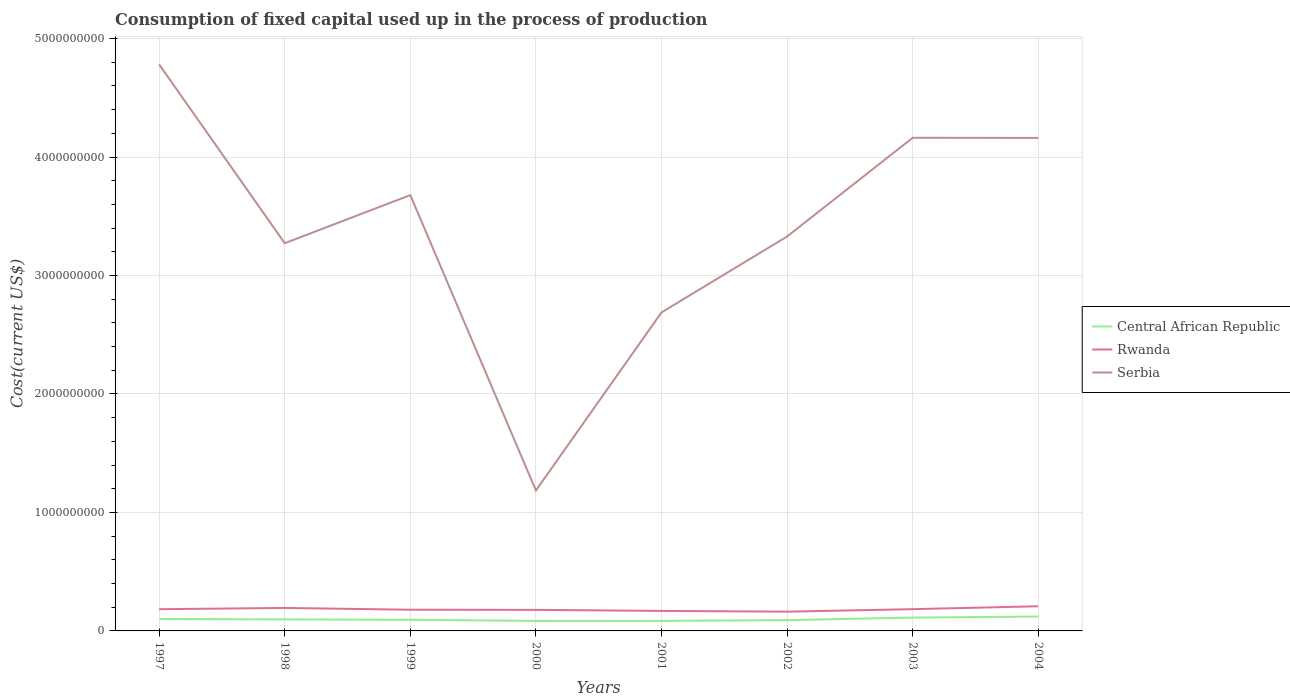How many different coloured lines are there?
Ensure brevity in your answer.  3. Does the line corresponding to Rwanda intersect with the line corresponding to Central African Republic?
Keep it short and to the point. No. Is the number of lines equal to the number of legend labels?
Provide a short and direct response. Yes. Across all years, what is the maximum amount consumed in the process of production in Rwanda?
Make the answer very short. 1.63e+08. What is the total amount consumed in the process of production in Rwanda in the graph?
Offer a terse response. -4.54e+07. What is the difference between the highest and the second highest amount consumed in the process of production in Rwanda?
Offer a very short reply. 4.54e+07. Is the amount consumed in the process of production in Rwanda strictly greater than the amount consumed in the process of production in Serbia over the years?
Your answer should be very brief. Yes. How many lines are there?
Make the answer very short. 3. What is the difference between two consecutive major ticks on the Y-axis?
Keep it short and to the point. 1.00e+09. Are the values on the major ticks of Y-axis written in scientific E-notation?
Your answer should be very brief. No. Where does the legend appear in the graph?
Provide a succinct answer. Center right. What is the title of the graph?
Give a very brief answer. Consumption of fixed capital used up in the process of production. What is the label or title of the X-axis?
Provide a succinct answer. Years. What is the label or title of the Y-axis?
Your response must be concise. Cost(current US$). What is the Cost(current US$) of Central African Republic in 1997?
Provide a short and direct response. 1.01e+08. What is the Cost(current US$) of Rwanda in 1997?
Ensure brevity in your answer.  1.83e+08. What is the Cost(current US$) of Serbia in 1997?
Your response must be concise. 4.78e+09. What is the Cost(current US$) of Central African Republic in 1998?
Provide a succinct answer. 9.70e+07. What is the Cost(current US$) of Rwanda in 1998?
Your answer should be very brief. 1.94e+08. What is the Cost(current US$) of Serbia in 1998?
Your answer should be very brief. 3.27e+09. What is the Cost(current US$) of Central African Republic in 1999?
Provide a short and direct response. 9.39e+07. What is the Cost(current US$) in Rwanda in 1999?
Offer a very short reply. 1.79e+08. What is the Cost(current US$) in Serbia in 1999?
Give a very brief answer. 3.68e+09. What is the Cost(current US$) of Central African Republic in 2000?
Offer a terse response. 8.47e+07. What is the Cost(current US$) in Rwanda in 2000?
Ensure brevity in your answer.  1.78e+08. What is the Cost(current US$) of Serbia in 2000?
Make the answer very short. 1.19e+09. What is the Cost(current US$) in Central African Republic in 2001?
Offer a terse response. 8.50e+07. What is the Cost(current US$) in Rwanda in 2001?
Keep it short and to the point. 1.69e+08. What is the Cost(current US$) of Serbia in 2001?
Ensure brevity in your answer.  2.69e+09. What is the Cost(current US$) in Central African Republic in 2002?
Provide a short and direct response. 9.10e+07. What is the Cost(current US$) in Rwanda in 2002?
Make the answer very short. 1.63e+08. What is the Cost(current US$) in Serbia in 2002?
Provide a succinct answer. 3.33e+09. What is the Cost(current US$) of Central African Republic in 2003?
Keep it short and to the point. 1.12e+08. What is the Cost(current US$) of Rwanda in 2003?
Offer a terse response. 1.84e+08. What is the Cost(current US$) in Serbia in 2003?
Your response must be concise. 4.16e+09. What is the Cost(current US$) of Central African Republic in 2004?
Keep it short and to the point. 1.21e+08. What is the Cost(current US$) in Rwanda in 2004?
Your response must be concise. 2.08e+08. What is the Cost(current US$) in Serbia in 2004?
Give a very brief answer. 4.16e+09. Across all years, what is the maximum Cost(current US$) of Central African Republic?
Make the answer very short. 1.21e+08. Across all years, what is the maximum Cost(current US$) of Rwanda?
Keep it short and to the point. 2.08e+08. Across all years, what is the maximum Cost(current US$) in Serbia?
Provide a succinct answer. 4.78e+09. Across all years, what is the minimum Cost(current US$) in Central African Republic?
Your response must be concise. 8.47e+07. Across all years, what is the minimum Cost(current US$) in Rwanda?
Your response must be concise. 1.63e+08. Across all years, what is the minimum Cost(current US$) of Serbia?
Provide a short and direct response. 1.19e+09. What is the total Cost(current US$) in Central African Republic in the graph?
Keep it short and to the point. 7.86e+08. What is the total Cost(current US$) of Rwanda in the graph?
Provide a succinct answer. 1.46e+09. What is the total Cost(current US$) of Serbia in the graph?
Offer a very short reply. 2.73e+1. What is the difference between the Cost(current US$) in Central African Republic in 1997 and that in 1998?
Your answer should be compact. 3.67e+06. What is the difference between the Cost(current US$) in Rwanda in 1997 and that in 1998?
Ensure brevity in your answer.  -1.07e+07. What is the difference between the Cost(current US$) of Serbia in 1997 and that in 1998?
Make the answer very short. 1.51e+09. What is the difference between the Cost(current US$) in Central African Republic in 1997 and that in 1999?
Keep it short and to the point. 6.76e+06. What is the difference between the Cost(current US$) in Rwanda in 1997 and that in 1999?
Ensure brevity in your answer.  4.52e+06. What is the difference between the Cost(current US$) in Serbia in 1997 and that in 1999?
Give a very brief answer. 1.10e+09. What is the difference between the Cost(current US$) in Central African Republic in 1997 and that in 2000?
Keep it short and to the point. 1.60e+07. What is the difference between the Cost(current US$) in Rwanda in 1997 and that in 2000?
Provide a succinct answer. 5.64e+06. What is the difference between the Cost(current US$) of Serbia in 1997 and that in 2000?
Make the answer very short. 3.60e+09. What is the difference between the Cost(current US$) in Central African Republic in 1997 and that in 2001?
Keep it short and to the point. 1.57e+07. What is the difference between the Cost(current US$) of Rwanda in 1997 and that in 2001?
Give a very brief answer. 1.45e+07. What is the difference between the Cost(current US$) in Serbia in 1997 and that in 2001?
Provide a succinct answer. 2.09e+09. What is the difference between the Cost(current US$) of Central African Republic in 1997 and that in 2002?
Your answer should be very brief. 9.70e+06. What is the difference between the Cost(current US$) of Rwanda in 1997 and that in 2002?
Keep it short and to the point. 2.07e+07. What is the difference between the Cost(current US$) of Serbia in 1997 and that in 2002?
Provide a short and direct response. 1.45e+09. What is the difference between the Cost(current US$) of Central African Republic in 1997 and that in 2003?
Offer a very short reply. -1.18e+07. What is the difference between the Cost(current US$) of Rwanda in 1997 and that in 2003?
Provide a short and direct response. -2.88e+05. What is the difference between the Cost(current US$) of Serbia in 1997 and that in 2003?
Your response must be concise. 6.20e+08. What is the difference between the Cost(current US$) of Central African Republic in 1997 and that in 2004?
Provide a short and direct response. -2.05e+07. What is the difference between the Cost(current US$) in Rwanda in 1997 and that in 2004?
Provide a short and direct response. -2.47e+07. What is the difference between the Cost(current US$) in Serbia in 1997 and that in 2004?
Offer a very short reply. 6.21e+08. What is the difference between the Cost(current US$) in Central African Republic in 1998 and that in 1999?
Your answer should be very brief. 3.10e+06. What is the difference between the Cost(current US$) in Rwanda in 1998 and that in 1999?
Keep it short and to the point. 1.52e+07. What is the difference between the Cost(current US$) of Serbia in 1998 and that in 1999?
Your answer should be very brief. -4.06e+08. What is the difference between the Cost(current US$) of Central African Republic in 1998 and that in 2000?
Your answer should be very brief. 1.24e+07. What is the difference between the Cost(current US$) of Rwanda in 1998 and that in 2000?
Keep it short and to the point. 1.63e+07. What is the difference between the Cost(current US$) of Serbia in 1998 and that in 2000?
Provide a short and direct response. 2.09e+09. What is the difference between the Cost(current US$) of Central African Republic in 1998 and that in 2001?
Offer a terse response. 1.21e+07. What is the difference between the Cost(current US$) of Rwanda in 1998 and that in 2001?
Offer a very short reply. 2.52e+07. What is the difference between the Cost(current US$) in Serbia in 1998 and that in 2001?
Your answer should be compact. 5.84e+08. What is the difference between the Cost(current US$) of Central African Republic in 1998 and that in 2002?
Provide a succinct answer. 6.04e+06. What is the difference between the Cost(current US$) of Rwanda in 1998 and that in 2002?
Offer a very short reply. 3.14e+07. What is the difference between the Cost(current US$) in Serbia in 1998 and that in 2002?
Ensure brevity in your answer.  -5.67e+07. What is the difference between the Cost(current US$) in Central African Republic in 1998 and that in 2003?
Provide a short and direct response. -1.54e+07. What is the difference between the Cost(current US$) of Rwanda in 1998 and that in 2003?
Provide a succinct answer. 1.04e+07. What is the difference between the Cost(current US$) of Serbia in 1998 and that in 2003?
Make the answer very short. -8.90e+08. What is the difference between the Cost(current US$) of Central African Republic in 1998 and that in 2004?
Provide a succinct answer. -2.42e+07. What is the difference between the Cost(current US$) of Rwanda in 1998 and that in 2004?
Provide a short and direct response. -1.41e+07. What is the difference between the Cost(current US$) in Serbia in 1998 and that in 2004?
Your response must be concise. -8.89e+08. What is the difference between the Cost(current US$) of Central African Republic in 1999 and that in 2000?
Ensure brevity in your answer.  9.26e+06. What is the difference between the Cost(current US$) in Rwanda in 1999 and that in 2000?
Offer a terse response. 1.11e+06. What is the difference between the Cost(current US$) of Serbia in 1999 and that in 2000?
Provide a short and direct response. 2.49e+09. What is the difference between the Cost(current US$) of Central African Republic in 1999 and that in 2001?
Provide a succinct answer. 8.97e+06. What is the difference between the Cost(current US$) of Rwanda in 1999 and that in 2001?
Make the answer very short. 1.00e+07. What is the difference between the Cost(current US$) in Serbia in 1999 and that in 2001?
Give a very brief answer. 9.90e+08. What is the difference between the Cost(current US$) in Central African Republic in 1999 and that in 2002?
Keep it short and to the point. 2.94e+06. What is the difference between the Cost(current US$) in Rwanda in 1999 and that in 2002?
Your response must be concise. 1.62e+07. What is the difference between the Cost(current US$) of Serbia in 1999 and that in 2002?
Provide a short and direct response. 3.50e+08. What is the difference between the Cost(current US$) of Central African Republic in 1999 and that in 2003?
Offer a very short reply. -1.85e+07. What is the difference between the Cost(current US$) in Rwanda in 1999 and that in 2003?
Keep it short and to the point. -4.81e+06. What is the difference between the Cost(current US$) in Serbia in 1999 and that in 2003?
Keep it short and to the point. -4.84e+08. What is the difference between the Cost(current US$) of Central African Republic in 1999 and that in 2004?
Provide a succinct answer. -2.73e+07. What is the difference between the Cost(current US$) of Rwanda in 1999 and that in 2004?
Give a very brief answer. -2.92e+07. What is the difference between the Cost(current US$) of Serbia in 1999 and that in 2004?
Ensure brevity in your answer.  -4.83e+08. What is the difference between the Cost(current US$) in Central African Republic in 2000 and that in 2001?
Provide a succinct answer. -2.96e+05. What is the difference between the Cost(current US$) in Rwanda in 2000 and that in 2001?
Give a very brief answer. 8.90e+06. What is the difference between the Cost(current US$) of Serbia in 2000 and that in 2001?
Offer a very short reply. -1.50e+09. What is the difference between the Cost(current US$) of Central African Republic in 2000 and that in 2002?
Provide a short and direct response. -6.32e+06. What is the difference between the Cost(current US$) of Rwanda in 2000 and that in 2002?
Offer a terse response. 1.51e+07. What is the difference between the Cost(current US$) of Serbia in 2000 and that in 2002?
Your response must be concise. -2.14e+09. What is the difference between the Cost(current US$) of Central African Republic in 2000 and that in 2003?
Give a very brief answer. -2.78e+07. What is the difference between the Cost(current US$) of Rwanda in 2000 and that in 2003?
Give a very brief answer. -5.92e+06. What is the difference between the Cost(current US$) of Serbia in 2000 and that in 2003?
Provide a short and direct response. -2.98e+09. What is the difference between the Cost(current US$) in Central African Republic in 2000 and that in 2004?
Provide a short and direct response. -3.65e+07. What is the difference between the Cost(current US$) in Rwanda in 2000 and that in 2004?
Your response must be concise. -3.03e+07. What is the difference between the Cost(current US$) of Serbia in 2000 and that in 2004?
Offer a very short reply. -2.98e+09. What is the difference between the Cost(current US$) of Central African Republic in 2001 and that in 2002?
Make the answer very short. -6.03e+06. What is the difference between the Cost(current US$) in Rwanda in 2001 and that in 2002?
Keep it short and to the point. 6.20e+06. What is the difference between the Cost(current US$) in Serbia in 2001 and that in 2002?
Keep it short and to the point. -6.41e+08. What is the difference between the Cost(current US$) of Central African Republic in 2001 and that in 2003?
Make the answer very short. -2.75e+07. What is the difference between the Cost(current US$) of Rwanda in 2001 and that in 2003?
Give a very brief answer. -1.48e+07. What is the difference between the Cost(current US$) of Serbia in 2001 and that in 2003?
Your response must be concise. -1.47e+09. What is the difference between the Cost(current US$) of Central African Republic in 2001 and that in 2004?
Provide a short and direct response. -3.62e+07. What is the difference between the Cost(current US$) of Rwanda in 2001 and that in 2004?
Your response must be concise. -3.92e+07. What is the difference between the Cost(current US$) of Serbia in 2001 and that in 2004?
Your response must be concise. -1.47e+09. What is the difference between the Cost(current US$) in Central African Republic in 2002 and that in 2003?
Offer a very short reply. -2.15e+07. What is the difference between the Cost(current US$) of Rwanda in 2002 and that in 2003?
Provide a succinct answer. -2.10e+07. What is the difference between the Cost(current US$) in Serbia in 2002 and that in 2003?
Make the answer very short. -8.33e+08. What is the difference between the Cost(current US$) of Central African Republic in 2002 and that in 2004?
Make the answer very short. -3.02e+07. What is the difference between the Cost(current US$) of Rwanda in 2002 and that in 2004?
Your answer should be very brief. -4.54e+07. What is the difference between the Cost(current US$) of Serbia in 2002 and that in 2004?
Give a very brief answer. -8.32e+08. What is the difference between the Cost(current US$) of Central African Republic in 2003 and that in 2004?
Provide a short and direct response. -8.74e+06. What is the difference between the Cost(current US$) in Rwanda in 2003 and that in 2004?
Give a very brief answer. -2.44e+07. What is the difference between the Cost(current US$) of Serbia in 2003 and that in 2004?
Give a very brief answer. 1.14e+06. What is the difference between the Cost(current US$) in Central African Republic in 1997 and the Cost(current US$) in Rwanda in 1998?
Give a very brief answer. -9.33e+07. What is the difference between the Cost(current US$) of Central African Republic in 1997 and the Cost(current US$) of Serbia in 1998?
Provide a succinct answer. -3.17e+09. What is the difference between the Cost(current US$) of Rwanda in 1997 and the Cost(current US$) of Serbia in 1998?
Provide a short and direct response. -3.09e+09. What is the difference between the Cost(current US$) of Central African Republic in 1997 and the Cost(current US$) of Rwanda in 1999?
Your answer should be compact. -7.82e+07. What is the difference between the Cost(current US$) of Central African Republic in 1997 and the Cost(current US$) of Serbia in 1999?
Provide a short and direct response. -3.58e+09. What is the difference between the Cost(current US$) in Rwanda in 1997 and the Cost(current US$) in Serbia in 1999?
Give a very brief answer. -3.50e+09. What is the difference between the Cost(current US$) of Central African Republic in 1997 and the Cost(current US$) of Rwanda in 2000?
Offer a terse response. -7.70e+07. What is the difference between the Cost(current US$) of Central African Republic in 1997 and the Cost(current US$) of Serbia in 2000?
Your answer should be compact. -1.08e+09. What is the difference between the Cost(current US$) of Rwanda in 1997 and the Cost(current US$) of Serbia in 2000?
Make the answer very short. -1.00e+09. What is the difference between the Cost(current US$) in Central African Republic in 1997 and the Cost(current US$) in Rwanda in 2001?
Your response must be concise. -6.81e+07. What is the difference between the Cost(current US$) of Central African Republic in 1997 and the Cost(current US$) of Serbia in 2001?
Ensure brevity in your answer.  -2.59e+09. What is the difference between the Cost(current US$) of Rwanda in 1997 and the Cost(current US$) of Serbia in 2001?
Make the answer very short. -2.51e+09. What is the difference between the Cost(current US$) in Central African Republic in 1997 and the Cost(current US$) in Rwanda in 2002?
Give a very brief answer. -6.19e+07. What is the difference between the Cost(current US$) of Central African Republic in 1997 and the Cost(current US$) of Serbia in 2002?
Offer a very short reply. -3.23e+09. What is the difference between the Cost(current US$) of Rwanda in 1997 and the Cost(current US$) of Serbia in 2002?
Provide a short and direct response. -3.15e+09. What is the difference between the Cost(current US$) in Central African Republic in 1997 and the Cost(current US$) in Rwanda in 2003?
Provide a short and direct response. -8.30e+07. What is the difference between the Cost(current US$) in Central African Republic in 1997 and the Cost(current US$) in Serbia in 2003?
Your answer should be compact. -4.06e+09. What is the difference between the Cost(current US$) in Rwanda in 1997 and the Cost(current US$) in Serbia in 2003?
Your answer should be very brief. -3.98e+09. What is the difference between the Cost(current US$) in Central African Republic in 1997 and the Cost(current US$) in Rwanda in 2004?
Your answer should be compact. -1.07e+08. What is the difference between the Cost(current US$) in Central African Republic in 1997 and the Cost(current US$) in Serbia in 2004?
Ensure brevity in your answer.  -4.06e+09. What is the difference between the Cost(current US$) in Rwanda in 1997 and the Cost(current US$) in Serbia in 2004?
Ensure brevity in your answer.  -3.98e+09. What is the difference between the Cost(current US$) of Central African Republic in 1998 and the Cost(current US$) of Rwanda in 1999?
Your response must be concise. -8.18e+07. What is the difference between the Cost(current US$) of Central African Republic in 1998 and the Cost(current US$) of Serbia in 1999?
Ensure brevity in your answer.  -3.58e+09. What is the difference between the Cost(current US$) of Rwanda in 1998 and the Cost(current US$) of Serbia in 1999?
Provide a short and direct response. -3.48e+09. What is the difference between the Cost(current US$) of Central African Republic in 1998 and the Cost(current US$) of Rwanda in 2000?
Offer a very short reply. -8.07e+07. What is the difference between the Cost(current US$) of Central African Republic in 1998 and the Cost(current US$) of Serbia in 2000?
Give a very brief answer. -1.09e+09. What is the difference between the Cost(current US$) in Rwanda in 1998 and the Cost(current US$) in Serbia in 2000?
Ensure brevity in your answer.  -9.91e+08. What is the difference between the Cost(current US$) of Central African Republic in 1998 and the Cost(current US$) of Rwanda in 2001?
Offer a terse response. -7.18e+07. What is the difference between the Cost(current US$) in Central African Republic in 1998 and the Cost(current US$) in Serbia in 2001?
Ensure brevity in your answer.  -2.59e+09. What is the difference between the Cost(current US$) of Rwanda in 1998 and the Cost(current US$) of Serbia in 2001?
Your answer should be very brief. -2.49e+09. What is the difference between the Cost(current US$) of Central African Republic in 1998 and the Cost(current US$) of Rwanda in 2002?
Your answer should be compact. -6.56e+07. What is the difference between the Cost(current US$) in Central African Republic in 1998 and the Cost(current US$) in Serbia in 2002?
Give a very brief answer. -3.23e+09. What is the difference between the Cost(current US$) in Rwanda in 1998 and the Cost(current US$) in Serbia in 2002?
Make the answer very short. -3.14e+09. What is the difference between the Cost(current US$) in Central African Republic in 1998 and the Cost(current US$) in Rwanda in 2003?
Ensure brevity in your answer.  -8.66e+07. What is the difference between the Cost(current US$) in Central African Republic in 1998 and the Cost(current US$) in Serbia in 2003?
Provide a succinct answer. -4.07e+09. What is the difference between the Cost(current US$) of Rwanda in 1998 and the Cost(current US$) of Serbia in 2003?
Offer a very short reply. -3.97e+09. What is the difference between the Cost(current US$) of Central African Republic in 1998 and the Cost(current US$) of Rwanda in 2004?
Your answer should be compact. -1.11e+08. What is the difference between the Cost(current US$) of Central African Republic in 1998 and the Cost(current US$) of Serbia in 2004?
Offer a very short reply. -4.06e+09. What is the difference between the Cost(current US$) of Rwanda in 1998 and the Cost(current US$) of Serbia in 2004?
Give a very brief answer. -3.97e+09. What is the difference between the Cost(current US$) in Central African Republic in 1999 and the Cost(current US$) in Rwanda in 2000?
Provide a succinct answer. -8.38e+07. What is the difference between the Cost(current US$) of Central African Republic in 1999 and the Cost(current US$) of Serbia in 2000?
Offer a terse response. -1.09e+09. What is the difference between the Cost(current US$) of Rwanda in 1999 and the Cost(current US$) of Serbia in 2000?
Ensure brevity in your answer.  -1.01e+09. What is the difference between the Cost(current US$) of Central African Republic in 1999 and the Cost(current US$) of Rwanda in 2001?
Your response must be concise. -7.49e+07. What is the difference between the Cost(current US$) in Central African Republic in 1999 and the Cost(current US$) in Serbia in 2001?
Provide a succinct answer. -2.59e+09. What is the difference between the Cost(current US$) of Rwanda in 1999 and the Cost(current US$) of Serbia in 2001?
Provide a short and direct response. -2.51e+09. What is the difference between the Cost(current US$) in Central African Republic in 1999 and the Cost(current US$) in Rwanda in 2002?
Provide a succinct answer. -6.87e+07. What is the difference between the Cost(current US$) of Central African Republic in 1999 and the Cost(current US$) of Serbia in 2002?
Provide a succinct answer. -3.24e+09. What is the difference between the Cost(current US$) of Rwanda in 1999 and the Cost(current US$) of Serbia in 2002?
Keep it short and to the point. -3.15e+09. What is the difference between the Cost(current US$) of Central African Republic in 1999 and the Cost(current US$) of Rwanda in 2003?
Ensure brevity in your answer.  -8.97e+07. What is the difference between the Cost(current US$) of Central African Republic in 1999 and the Cost(current US$) of Serbia in 2003?
Provide a short and direct response. -4.07e+09. What is the difference between the Cost(current US$) of Rwanda in 1999 and the Cost(current US$) of Serbia in 2003?
Your response must be concise. -3.98e+09. What is the difference between the Cost(current US$) of Central African Republic in 1999 and the Cost(current US$) of Rwanda in 2004?
Provide a succinct answer. -1.14e+08. What is the difference between the Cost(current US$) of Central African Republic in 1999 and the Cost(current US$) of Serbia in 2004?
Keep it short and to the point. -4.07e+09. What is the difference between the Cost(current US$) of Rwanda in 1999 and the Cost(current US$) of Serbia in 2004?
Give a very brief answer. -3.98e+09. What is the difference between the Cost(current US$) in Central African Republic in 2000 and the Cost(current US$) in Rwanda in 2001?
Your response must be concise. -8.42e+07. What is the difference between the Cost(current US$) in Central African Republic in 2000 and the Cost(current US$) in Serbia in 2001?
Give a very brief answer. -2.60e+09. What is the difference between the Cost(current US$) in Rwanda in 2000 and the Cost(current US$) in Serbia in 2001?
Make the answer very short. -2.51e+09. What is the difference between the Cost(current US$) in Central African Republic in 2000 and the Cost(current US$) in Rwanda in 2002?
Your response must be concise. -7.80e+07. What is the difference between the Cost(current US$) of Central African Republic in 2000 and the Cost(current US$) of Serbia in 2002?
Your answer should be compact. -3.24e+09. What is the difference between the Cost(current US$) of Rwanda in 2000 and the Cost(current US$) of Serbia in 2002?
Keep it short and to the point. -3.15e+09. What is the difference between the Cost(current US$) of Central African Republic in 2000 and the Cost(current US$) of Rwanda in 2003?
Your response must be concise. -9.90e+07. What is the difference between the Cost(current US$) in Central African Republic in 2000 and the Cost(current US$) in Serbia in 2003?
Your response must be concise. -4.08e+09. What is the difference between the Cost(current US$) in Rwanda in 2000 and the Cost(current US$) in Serbia in 2003?
Your response must be concise. -3.99e+09. What is the difference between the Cost(current US$) of Central African Republic in 2000 and the Cost(current US$) of Rwanda in 2004?
Offer a terse response. -1.23e+08. What is the difference between the Cost(current US$) of Central African Republic in 2000 and the Cost(current US$) of Serbia in 2004?
Provide a short and direct response. -4.08e+09. What is the difference between the Cost(current US$) of Rwanda in 2000 and the Cost(current US$) of Serbia in 2004?
Keep it short and to the point. -3.98e+09. What is the difference between the Cost(current US$) of Central African Republic in 2001 and the Cost(current US$) of Rwanda in 2002?
Keep it short and to the point. -7.77e+07. What is the difference between the Cost(current US$) of Central African Republic in 2001 and the Cost(current US$) of Serbia in 2002?
Make the answer very short. -3.24e+09. What is the difference between the Cost(current US$) of Rwanda in 2001 and the Cost(current US$) of Serbia in 2002?
Give a very brief answer. -3.16e+09. What is the difference between the Cost(current US$) in Central African Republic in 2001 and the Cost(current US$) in Rwanda in 2003?
Make the answer very short. -9.87e+07. What is the difference between the Cost(current US$) in Central African Republic in 2001 and the Cost(current US$) in Serbia in 2003?
Offer a terse response. -4.08e+09. What is the difference between the Cost(current US$) of Rwanda in 2001 and the Cost(current US$) of Serbia in 2003?
Your answer should be very brief. -3.99e+09. What is the difference between the Cost(current US$) of Central African Republic in 2001 and the Cost(current US$) of Rwanda in 2004?
Offer a terse response. -1.23e+08. What is the difference between the Cost(current US$) of Central African Republic in 2001 and the Cost(current US$) of Serbia in 2004?
Give a very brief answer. -4.08e+09. What is the difference between the Cost(current US$) of Rwanda in 2001 and the Cost(current US$) of Serbia in 2004?
Your response must be concise. -3.99e+09. What is the difference between the Cost(current US$) in Central African Republic in 2002 and the Cost(current US$) in Rwanda in 2003?
Give a very brief answer. -9.27e+07. What is the difference between the Cost(current US$) in Central African Republic in 2002 and the Cost(current US$) in Serbia in 2003?
Offer a terse response. -4.07e+09. What is the difference between the Cost(current US$) in Rwanda in 2002 and the Cost(current US$) in Serbia in 2003?
Offer a very short reply. -4.00e+09. What is the difference between the Cost(current US$) of Central African Republic in 2002 and the Cost(current US$) of Rwanda in 2004?
Make the answer very short. -1.17e+08. What is the difference between the Cost(current US$) of Central African Republic in 2002 and the Cost(current US$) of Serbia in 2004?
Your answer should be compact. -4.07e+09. What is the difference between the Cost(current US$) in Rwanda in 2002 and the Cost(current US$) in Serbia in 2004?
Provide a succinct answer. -4.00e+09. What is the difference between the Cost(current US$) of Central African Republic in 2003 and the Cost(current US$) of Rwanda in 2004?
Offer a terse response. -9.56e+07. What is the difference between the Cost(current US$) of Central African Republic in 2003 and the Cost(current US$) of Serbia in 2004?
Offer a terse response. -4.05e+09. What is the difference between the Cost(current US$) in Rwanda in 2003 and the Cost(current US$) in Serbia in 2004?
Provide a short and direct response. -3.98e+09. What is the average Cost(current US$) of Central African Republic per year?
Provide a short and direct response. 9.82e+07. What is the average Cost(current US$) of Rwanda per year?
Ensure brevity in your answer.  1.82e+08. What is the average Cost(current US$) of Serbia per year?
Keep it short and to the point. 3.41e+09. In the year 1997, what is the difference between the Cost(current US$) in Central African Republic and Cost(current US$) in Rwanda?
Your response must be concise. -8.27e+07. In the year 1997, what is the difference between the Cost(current US$) in Central African Republic and Cost(current US$) in Serbia?
Your answer should be compact. -4.68e+09. In the year 1997, what is the difference between the Cost(current US$) in Rwanda and Cost(current US$) in Serbia?
Ensure brevity in your answer.  -4.60e+09. In the year 1998, what is the difference between the Cost(current US$) in Central African Republic and Cost(current US$) in Rwanda?
Ensure brevity in your answer.  -9.70e+07. In the year 1998, what is the difference between the Cost(current US$) in Central African Republic and Cost(current US$) in Serbia?
Provide a short and direct response. -3.18e+09. In the year 1998, what is the difference between the Cost(current US$) in Rwanda and Cost(current US$) in Serbia?
Ensure brevity in your answer.  -3.08e+09. In the year 1999, what is the difference between the Cost(current US$) in Central African Republic and Cost(current US$) in Rwanda?
Ensure brevity in your answer.  -8.49e+07. In the year 1999, what is the difference between the Cost(current US$) of Central African Republic and Cost(current US$) of Serbia?
Provide a short and direct response. -3.58e+09. In the year 1999, what is the difference between the Cost(current US$) in Rwanda and Cost(current US$) in Serbia?
Make the answer very short. -3.50e+09. In the year 2000, what is the difference between the Cost(current US$) in Central African Republic and Cost(current US$) in Rwanda?
Offer a very short reply. -9.31e+07. In the year 2000, what is the difference between the Cost(current US$) of Central African Republic and Cost(current US$) of Serbia?
Provide a succinct answer. -1.10e+09. In the year 2000, what is the difference between the Cost(current US$) in Rwanda and Cost(current US$) in Serbia?
Offer a terse response. -1.01e+09. In the year 2001, what is the difference between the Cost(current US$) in Central African Republic and Cost(current US$) in Rwanda?
Keep it short and to the point. -8.39e+07. In the year 2001, what is the difference between the Cost(current US$) of Central African Republic and Cost(current US$) of Serbia?
Ensure brevity in your answer.  -2.60e+09. In the year 2001, what is the difference between the Cost(current US$) of Rwanda and Cost(current US$) of Serbia?
Offer a terse response. -2.52e+09. In the year 2002, what is the difference between the Cost(current US$) of Central African Republic and Cost(current US$) of Rwanda?
Keep it short and to the point. -7.16e+07. In the year 2002, what is the difference between the Cost(current US$) of Central African Republic and Cost(current US$) of Serbia?
Your answer should be compact. -3.24e+09. In the year 2002, what is the difference between the Cost(current US$) in Rwanda and Cost(current US$) in Serbia?
Keep it short and to the point. -3.17e+09. In the year 2003, what is the difference between the Cost(current US$) of Central African Republic and Cost(current US$) of Rwanda?
Provide a succinct answer. -7.12e+07. In the year 2003, what is the difference between the Cost(current US$) in Central African Republic and Cost(current US$) in Serbia?
Give a very brief answer. -4.05e+09. In the year 2003, what is the difference between the Cost(current US$) in Rwanda and Cost(current US$) in Serbia?
Offer a very short reply. -3.98e+09. In the year 2004, what is the difference between the Cost(current US$) in Central African Republic and Cost(current US$) in Rwanda?
Keep it short and to the point. -8.69e+07. In the year 2004, what is the difference between the Cost(current US$) in Central African Republic and Cost(current US$) in Serbia?
Your answer should be very brief. -4.04e+09. In the year 2004, what is the difference between the Cost(current US$) of Rwanda and Cost(current US$) of Serbia?
Your response must be concise. -3.95e+09. What is the ratio of the Cost(current US$) of Central African Republic in 1997 to that in 1998?
Provide a short and direct response. 1.04. What is the ratio of the Cost(current US$) of Rwanda in 1997 to that in 1998?
Ensure brevity in your answer.  0.95. What is the ratio of the Cost(current US$) of Serbia in 1997 to that in 1998?
Provide a succinct answer. 1.46. What is the ratio of the Cost(current US$) of Central African Republic in 1997 to that in 1999?
Make the answer very short. 1.07. What is the ratio of the Cost(current US$) in Rwanda in 1997 to that in 1999?
Provide a succinct answer. 1.03. What is the ratio of the Cost(current US$) in Serbia in 1997 to that in 1999?
Keep it short and to the point. 1.3. What is the ratio of the Cost(current US$) of Central African Republic in 1997 to that in 2000?
Keep it short and to the point. 1.19. What is the ratio of the Cost(current US$) in Rwanda in 1997 to that in 2000?
Provide a short and direct response. 1.03. What is the ratio of the Cost(current US$) in Serbia in 1997 to that in 2000?
Your answer should be very brief. 4.03. What is the ratio of the Cost(current US$) in Central African Republic in 1997 to that in 2001?
Provide a succinct answer. 1.19. What is the ratio of the Cost(current US$) of Rwanda in 1997 to that in 2001?
Offer a terse response. 1.09. What is the ratio of the Cost(current US$) of Serbia in 1997 to that in 2001?
Offer a terse response. 1.78. What is the ratio of the Cost(current US$) in Central African Republic in 1997 to that in 2002?
Make the answer very short. 1.11. What is the ratio of the Cost(current US$) in Rwanda in 1997 to that in 2002?
Provide a succinct answer. 1.13. What is the ratio of the Cost(current US$) in Serbia in 1997 to that in 2002?
Your answer should be compact. 1.44. What is the ratio of the Cost(current US$) of Central African Republic in 1997 to that in 2003?
Provide a succinct answer. 0.9. What is the ratio of the Cost(current US$) of Rwanda in 1997 to that in 2003?
Offer a terse response. 1. What is the ratio of the Cost(current US$) in Serbia in 1997 to that in 2003?
Your answer should be compact. 1.15. What is the ratio of the Cost(current US$) of Central African Republic in 1997 to that in 2004?
Your response must be concise. 0.83. What is the ratio of the Cost(current US$) of Rwanda in 1997 to that in 2004?
Offer a terse response. 0.88. What is the ratio of the Cost(current US$) in Serbia in 1997 to that in 2004?
Your response must be concise. 1.15. What is the ratio of the Cost(current US$) of Central African Republic in 1998 to that in 1999?
Provide a succinct answer. 1.03. What is the ratio of the Cost(current US$) in Rwanda in 1998 to that in 1999?
Make the answer very short. 1.08. What is the ratio of the Cost(current US$) of Serbia in 1998 to that in 1999?
Your answer should be compact. 0.89. What is the ratio of the Cost(current US$) of Central African Republic in 1998 to that in 2000?
Provide a succinct answer. 1.15. What is the ratio of the Cost(current US$) of Rwanda in 1998 to that in 2000?
Give a very brief answer. 1.09. What is the ratio of the Cost(current US$) of Serbia in 1998 to that in 2000?
Make the answer very short. 2.76. What is the ratio of the Cost(current US$) in Central African Republic in 1998 to that in 2001?
Your answer should be very brief. 1.14. What is the ratio of the Cost(current US$) of Rwanda in 1998 to that in 2001?
Your answer should be very brief. 1.15. What is the ratio of the Cost(current US$) of Serbia in 1998 to that in 2001?
Offer a very short reply. 1.22. What is the ratio of the Cost(current US$) in Central African Republic in 1998 to that in 2002?
Provide a succinct answer. 1.07. What is the ratio of the Cost(current US$) of Rwanda in 1998 to that in 2002?
Ensure brevity in your answer.  1.19. What is the ratio of the Cost(current US$) in Central African Republic in 1998 to that in 2003?
Your answer should be very brief. 0.86. What is the ratio of the Cost(current US$) of Rwanda in 1998 to that in 2003?
Provide a succinct answer. 1.06. What is the ratio of the Cost(current US$) of Serbia in 1998 to that in 2003?
Offer a very short reply. 0.79. What is the ratio of the Cost(current US$) of Central African Republic in 1998 to that in 2004?
Your answer should be compact. 0.8. What is the ratio of the Cost(current US$) in Rwanda in 1998 to that in 2004?
Give a very brief answer. 0.93. What is the ratio of the Cost(current US$) in Serbia in 1998 to that in 2004?
Offer a terse response. 0.79. What is the ratio of the Cost(current US$) of Central African Republic in 1999 to that in 2000?
Provide a succinct answer. 1.11. What is the ratio of the Cost(current US$) of Rwanda in 1999 to that in 2000?
Make the answer very short. 1.01. What is the ratio of the Cost(current US$) in Serbia in 1999 to that in 2000?
Give a very brief answer. 3.1. What is the ratio of the Cost(current US$) in Central African Republic in 1999 to that in 2001?
Offer a very short reply. 1.11. What is the ratio of the Cost(current US$) of Rwanda in 1999 to that in 2001?
Your answer should be compact. 1.06. What is the ratio of the Cost(current US$) in Serbia in 1999 to that in 2001?
Keep it short and to the point. 1.37. What is the ratio of the Cost(current US$) in Central African Republic in 1999 to that in 2002?
Ensure brevity in your answer.  1.03. What is the ratio of the Cost(current US$) in Rwanda in 1999 to that in 2002?
Your answer should be compact. 1.1. What is the ratio of the Cost(current US$) of Serbia in 1999 to that in 2002?
Your response must be concise. 1.1. What is the ratio of the Cost(current US$) of Central African Republic in 1999 to that in 2003?
Provide a short and direct response. 0.84. What is the ratio of the Cost(current US$) of Rwanda in 1999 to that in 2003?
Your answer should be compact. 0.97. What is the ratio of the Cost(current US$) in Serbia in 1999 to that in 2003?
Your answer should be compact. 0.88. What is the ratio of the Cost(current US$) in Central African Republic in 1999 to that in 2004?
Your response must be concise. 0.78. What is the ratio of the Cost(current US$) in Rwanda in 1999 to that in 2004?
Your response must be concise. 0.86. What is the ratio of the Cost(current US$) in Serbia in 1999 to that in 2004?
Ensure brevity in your answer.  0.88. What is the ratio of the Cost(current US$) in Central African Republic in 2000 to that in 2001?
Keep it short and to the point. 1. What is the ratio of the Cost(current US$) of Rwanda in 2000 to that in 2001?
Your answer should be compact. 1.05. What is the ratio of the Cost(current US$) of Serbia in 2000 to that in 2001?
Offer a terse response. 0.44. What is the ratio of the Cost(current US$) in Central African Republic in 2000 to that in 2002?
Offer a terse response. 0.93. What is the ratio of the Cost(current US$) in Rwanda in 2000 to that in 2002?
Your answer should be very brief. 1.09. What is the ratio of the Cost(current US$) of Serbia in 2000 to that in 2002?
Provide a short and direct response. 0.36. What is the ratio of the Cost(current US$) of Central African Republic in 2000 to that in 2003?
Offer a very short reply. 0.75. What is the ratio of the Cost(current US$) of Rwanda in 2000 to that in 2003?
Ensure brevity in your answer.  0.97. What is the ratio of the Cost(current US$) of Serbia in 2000 to that in 2003?
Your answer should be very brief. 0.28. What is the ratio of the Cost(current US$) of Central African Republic in 2000 to that in 2004?
Provide a succinct answer. 0.7. What is the ratio of the Cost(current US$) in Rwanda in 2000 to that in 2004?
Provide a succinct answer. 0.85. What is the ratio of the Cost(current US$) in Serbia in 2000 to that in 2004?
Offer a very short reply. 0.28. What is the ratio of the Cost(current US$) of Central African Republic in 2001 to that in 2002?
Give a very brief answer. 0.93. What is the ratio of the Cost(current US$) in Rwanda in 2001 to that in 2002?
Offer a terse response. 1.04. What is the ratio of the Cost(current US$) in Serbia in 2001 to that in 2002?
Your answer should be very brief. 0.81. What is the ratio of the Cost(current US$) in Central African Republic in 2001 to that in 2003?
Offer a terse response. 0.76. What is the ratio of the Cost(current US$) of Rwanda in 2001 to that in 2003?
Offer a very short reply. 0.92. What is the ratio of the Cost(current US$) in Serbia in 2001 to that in 2003?
Ensure brevity in your answer.  0.65. What is the ratio of the Cost(current US$) of Central African Republic in 2001 to that in 2004?
Offer a terse response. 0.7. What is the ratio of the Cost(current US$) in Rwanda in 2001 to that in 2004?
Offer a terse response. 0.81. What is the ratio of the Cost(current US$) of Serbia in 2001 to that in 2004?
Ensure brevity in your answer.  0.65. What is the ratio of the Cost(current US$) in Central African Republic in 2002 to that in 2003?
Your response must be concise. 0.81. What is the ratio of the Cost(current US$) in Rwanda in 2002 to that in 2003?
Ensure brevity in your answer.  0.89. What is the ratio of the Cost(current US$) in Serbia in 2002 to that in 2003?
Provide a succinct answer. 0.8. What is the ratio of the Cost(current US$) of Central African Republic in 2002 to that in 2004?
Keep it short and to the point. 0.75. What is the ratio of the Cost(current US$) of Rwanda in 2002 to that in 2004?
Your answer should be very brief. 0.78. What is the ratio of the Cost(current US$) of Serbia in 2002 to that in 2004?
Offer a terse response. 0.8. What is the ratio of the Cost(current US$) in Central African Republic in 2003 to that in 2004?
Provide a short and direct response. 0.93. What is the ratio of the Cost(current US$) of Rwanda in 2003 to that in 2004?
Your answer should be compact. 0.88. What is the difference between the highest and the second highest Cost(current US$) of Central African Republic?
Keep it short and to the point. 8.74e+06. What is the difference between the highest and the second highest Cost(current US$) of Rwanda?
Your response must be concise. 1.41e+07. What is the difference between the highest and the second highest Cost(current US$) of Serbia?
Your response must be concise. 6.20e+08. What is the difference between the highest and the lowest Cost(current US$) of Central African Republic?
Give a very brief answer. 3.65e+07. What is the difference between the highest and the lowest Cost(current US$) in Rwanda?
Keep it short and to the point. 4.54e+07. What is the difference between the highest and the lowest Cost(current US$) in Serbia?
Your answer should be very brief. 3.60e+09. 